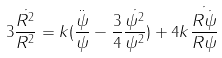Convert formula to latex. <formula><loc_0><loc_0><loc_500><loc_500>3 \frac { \dot { R ^ { 2 } } } { R ^ { 2 } } = k ( \frac { \ddot { \psi } } { \psi } - \frac { 3 } { 4 } \frac { \dot { \psi ^ { 2 } } } { \psi ^ { 2 } } ) + 4 k \frac { \dot { R \dot { \psi } } } { R \psi }</formula> 